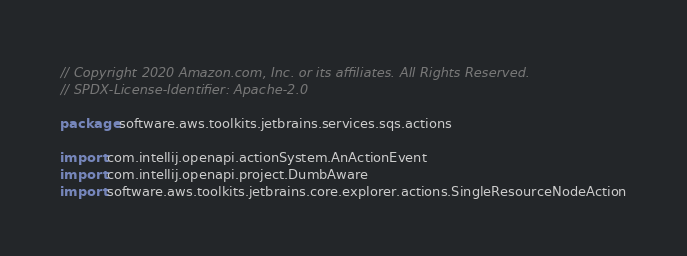<code> <loc_0><loc_0><loc_500><loc_500><_Kotlin_>// Copyright 2020 Amazon.com, Inc. or its affiliates. All Rights Reserved.
// SPDX-License-Identifier: Apache-2.0

package software.aws.toolkits.jetbrains.services.sqs.actions

import com.intellij.openapi.actionSystem.AnActionEvent
import com.intellij.openapi.project.DumbAware
import software.aws.toolkits.jetbrains.core.explorer.actions.SingleResourceNodeAction</code> 